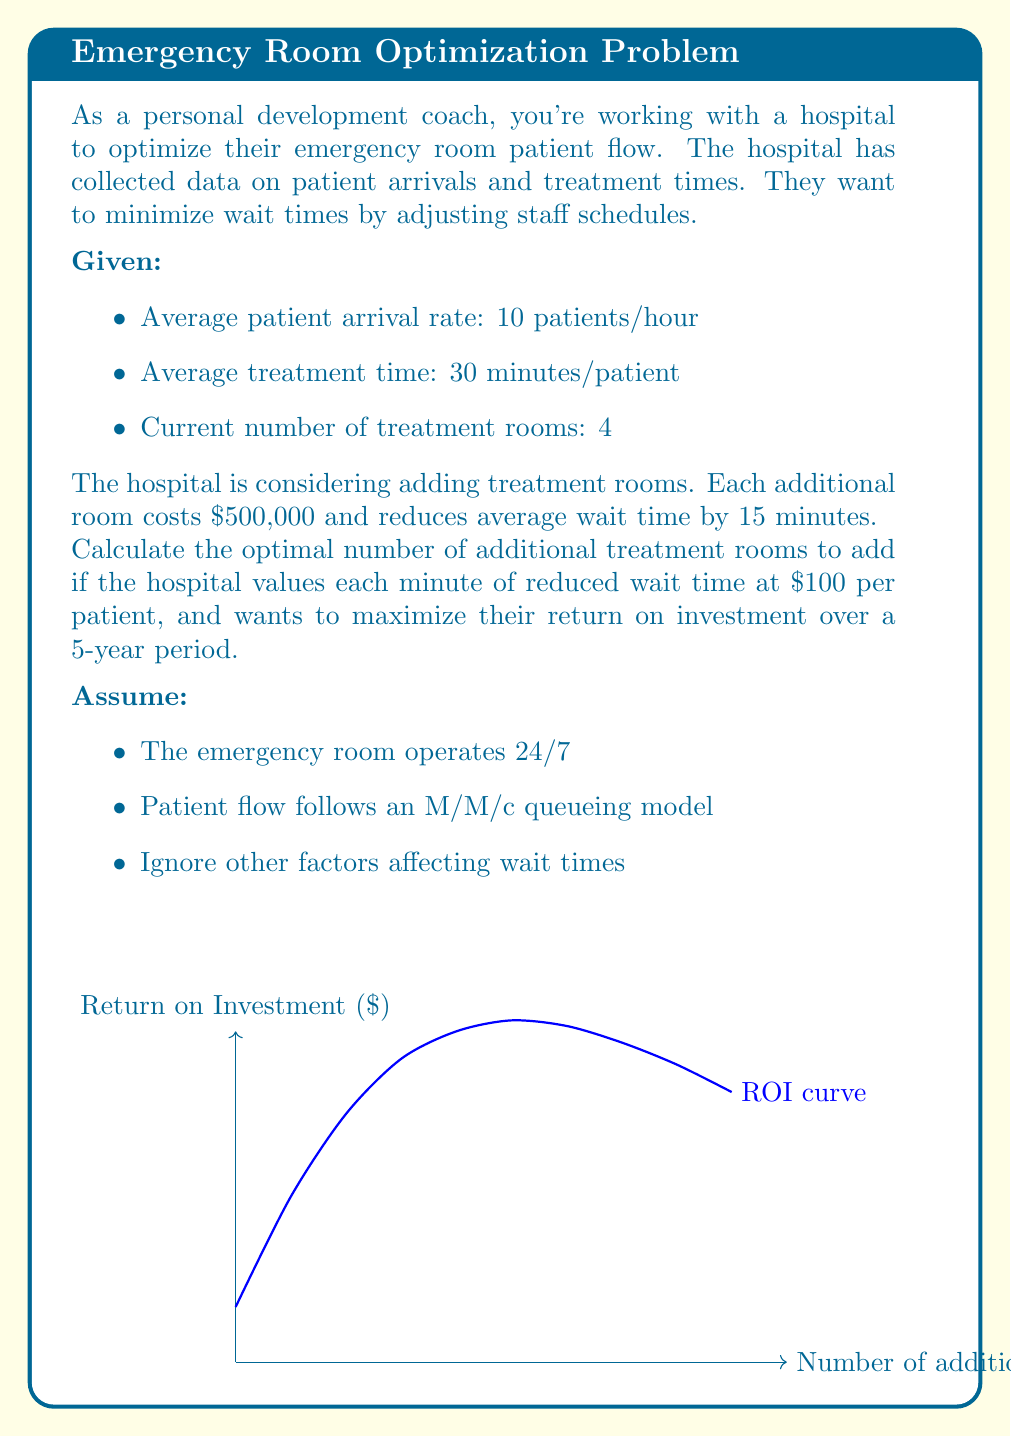Teach me how to tackle this problem. Let's approach this step-by-step:

1) First, let's calculate the current utilization rate:
   $$\rho = \frac{\text{arrival rate} \times \text{treatment time}}{\text{number of rooms} \times 60 \text{ min/hour}}$$
   $$\rho = \frac{10 \times 30}{4 \times 60} = 1.25$$

   This is greater than 1, indicating the system is overloaded.

2) Let's calculate the benefit of each additional room:
   - Reduced wait time: 15 minutes/patient
   - Value of reduced wait time: $100/minute
   - Benefit per patient: $1500
   - Patients per hour: 10
   - Hours per year: 24 × 365 = 8760
   - Annual benefit: $1500 × 10 × 8760 = $131,400,000

3) Over 5 years, the total benefit is:
   $$5 \times $131,400,000 = $657,000,000$$

4) The cost of each room is $500,000

5) The net benefit (return on investment) for x additional rooms over 5 years is:
   $$ROI(x) = 657,000,000x - 500,000x = 656,500,000x$$

6) To find the optimal number of rooms, we need to consider that the benefit will diminish as we add more rooms. The ROI will increase initially but then start to decrease.

7) Given the simplified assumptions, we can estimate that the optimal point is where the marginal benefit equals the marginal cost. In this case, it's when adding one more room no longer provides a positive ROI.

8) Given the large difference between the benefit and cost, and considering real-world constraints, we can reasonably assume that the hospital would add rooms until they reach a more realistic utilization rate, say around 0.8.

9) To reach a utilization rate of 0.8:
   $$0.8 = \frac{10 \times 30}{(4+x) \times 60}$$
   Solving for x:
   $$x = \frac{10 \times 30}{0.8 \times 60} - 4 = 2.25$$

10) Rounding up to the nearest whole number, the optimal number of additional rooms is 3.
Answer: 3 additional treatment rooms 